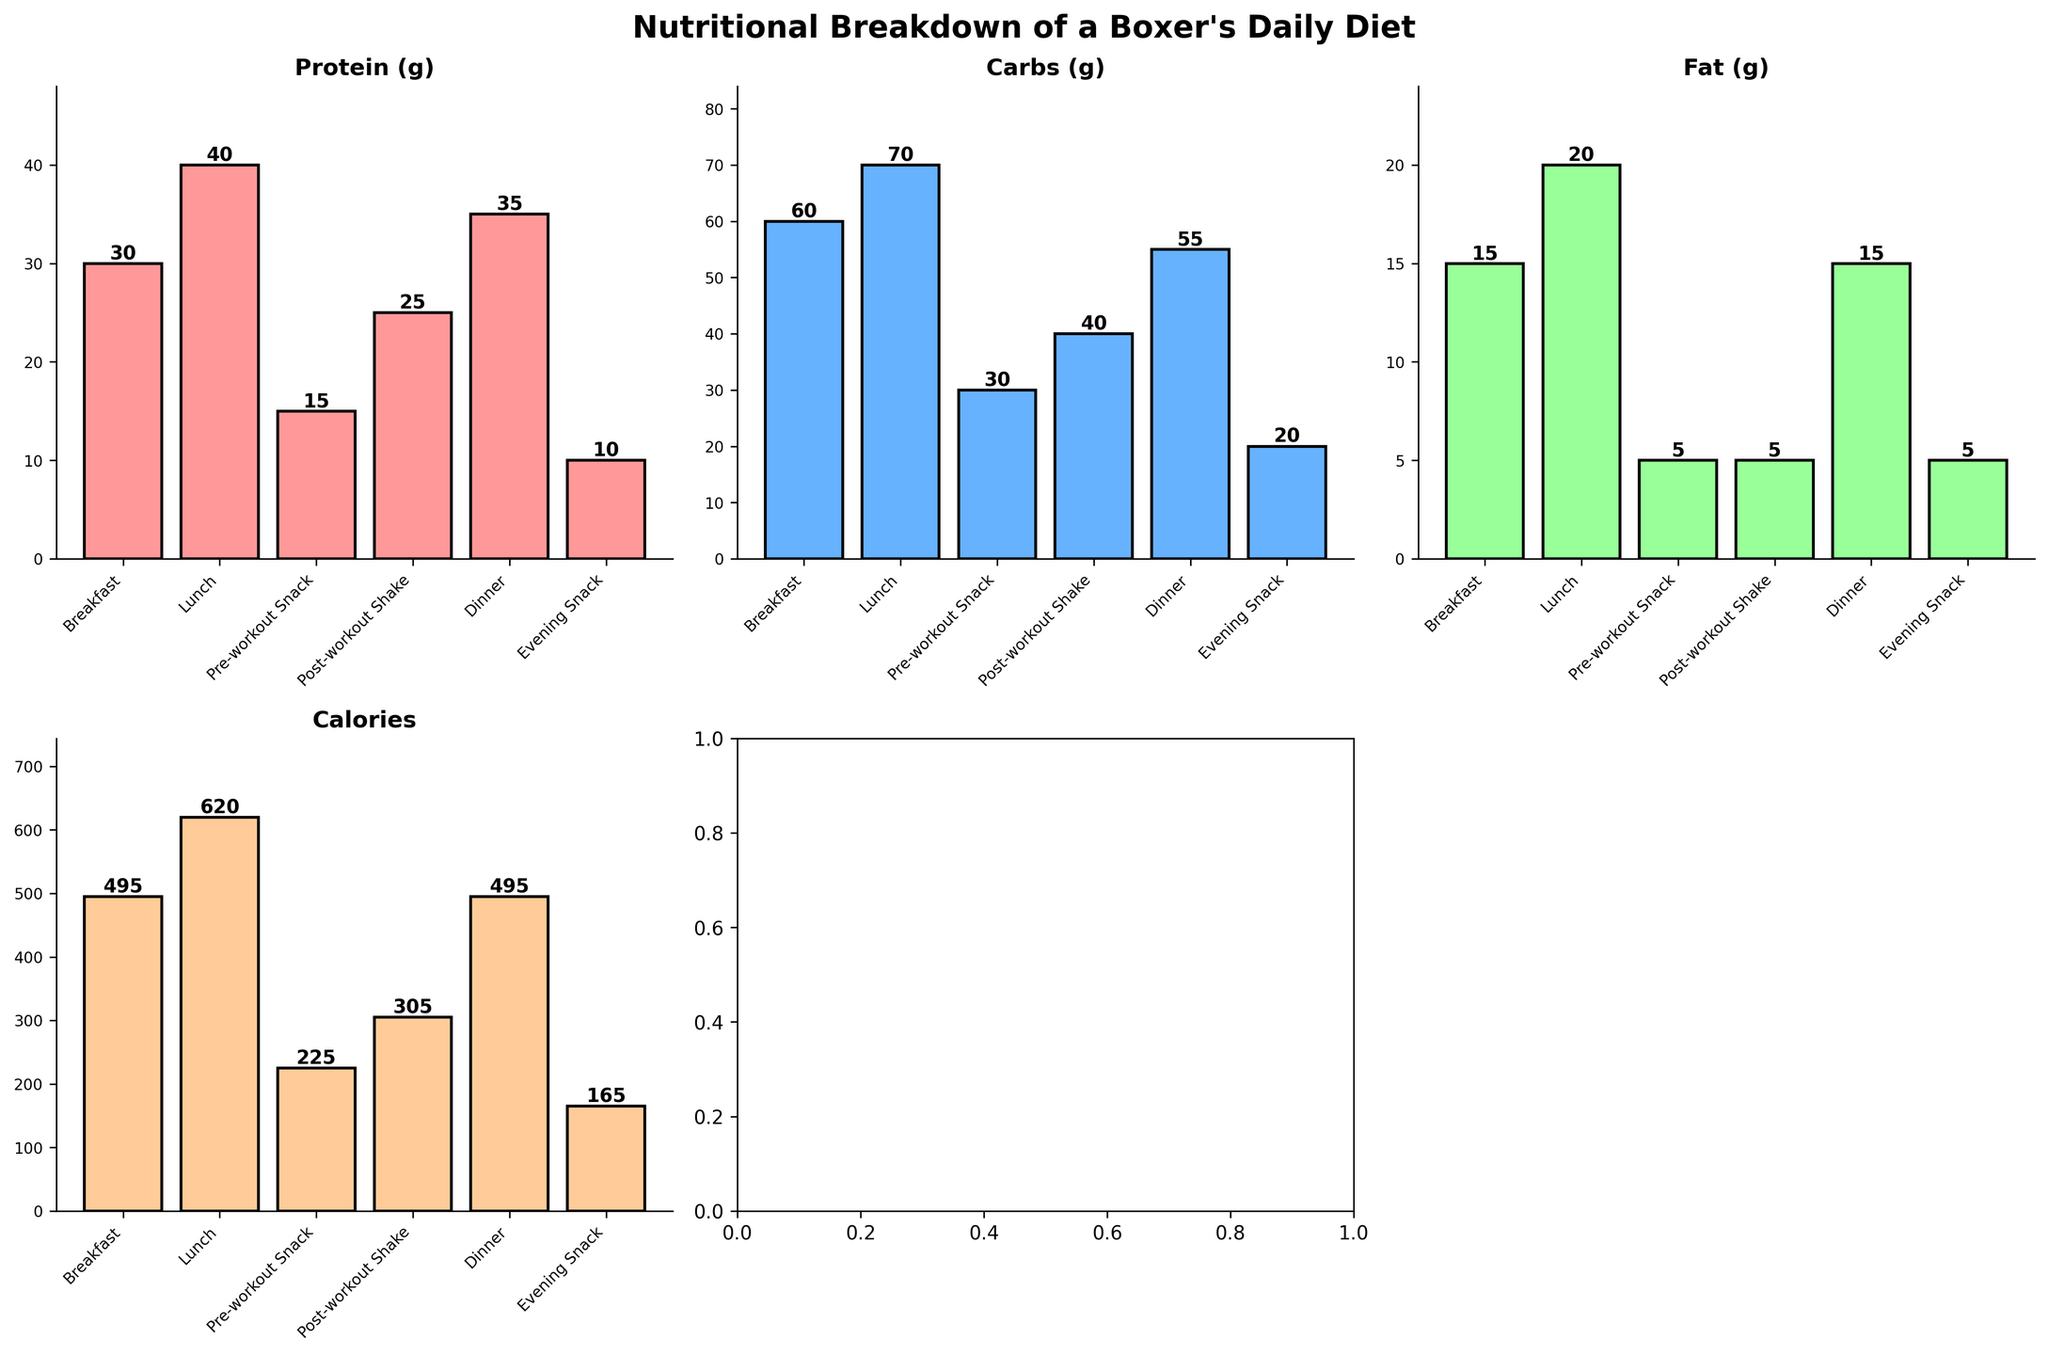How many meals are shown in the figure? The figure depicts the nutritional breakdown for different meals. Counting the bars or the labels on the x-axis of any subplot will give you the number of meals.
Answer: 6 What is the highest value for calories and which meal does it correspond to? Look for the tallest bar in the 'Calories' subplot and check the meal label associated with it. The tallest bar reaches 620 calories, indicating that Lunch corresponds to this value.
Answer: 620, Lunch How does the protein intake for breakfast compare to that of dinner? Check the height of the bars labeled 'Protein (g)' for Breakfast and Dinner. Both bars for these meals reach 30 g and 35 g, respectively.
Answer: Breakfast: 30 g, Dinner: 35 g What is the total carbohydrate intake from all meals? Sum the heights of the bars labeled 'Carbs (g)' for each meal: Breakfast (60 g) + Lunch (70 g) + Pre-workout Snack (30 g) + Post-workout Shake (40 g) + Dinner (55 g) + Evening Snack (20 g).
Answer: 275 g Which meal has the lowest fat content and what is its value? Identify the shortest bar in the 'Fat (g)' subplot and read the meal label and its value. The bars for Pre-workout Snack, Post-workout Shake, and Evening Snack all reach 5 g, but all represent different meals. One of these meals can be chosen as an example, such as Evening Snack.
Answer: Evening Snack, 5 g What is the average calorie count for all six meals? Add the heights of the bars labeled 'Calories' across all meals, then divide by 6: (495 + 620 + 225 + 305 + 495 + 165) / 6.
Answer: 384.2 calories Between Breakfast and Dinner, which meal has higher carbohydrate content and by how much? Compare the heights of the bars labeled 'Carbs (g)' for Breakfast (60 g) and Dinner (55 g). Calculate the difference: 60 g - 55 g.
Answer: Breakfast, 5 g more Which nutrient has the highest total intake across all meals? Sum the heights of the bars for each nutrient across all meals: Protein (30 + 40 + 15 + 25 + 35 + 10), Carbs (60 + 70 + 30 + 40 + 55 + 20), Fat (15 + 20 + 5 + 5 + 15 + 5), and Calories (495 + 620 + 225 + 305 + 495 + 165). Compare the totals: Protein (155), Carbs (275), Fat (65), Calories (2305).
Answer: Calories How does the fat intake for Lunch compare to the total fat intake of all snacks (Pre-workout Snack, Post-workout Shake, Evening Snack)? Look at the height of the bar labeled 'Fat (g)' for Lunch (20 g). Then add the heights of the bars for the two snacks: Pre-workout Snack (5 g) + Post-workout Shake (5 g) + Evening Snack (5 g).
Answer: Lunch: 20 g, Snacks total: 15 g Which meal has the maximum protein intake and what is its value? Identify the tallest bar in the 'Protein (g)' subplot and read the associated meal label and value. The tallest bar corresponds to Lunch at 40 g.
Answer: Lunch, 40 g 